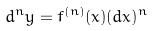<formula> <loc_0><loc_0><loc_500><loc_500>d ^ { n } y = f ^ { ( n ) } ( x ) ( d x ) ^ { n }</formula> 